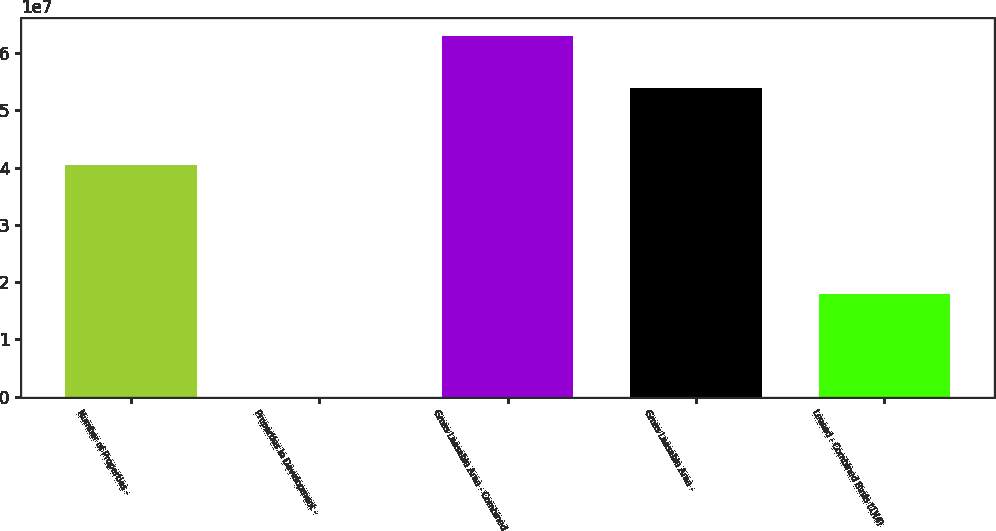Convert chart. <chart><loc_0><loc_0><loc_500><loc_500><bar_chart><fcel>Number of Properties -<fcel>Properties in Development -<fcel>Gross Leasable Area - Combined<fcel>Gross Leasable Area -<fcel>Leased - Combined Basis (1)(4)<nl><fcel>4.04748e+07<fcel>1<fcel>6.29607e+07<fcel>5.39664e+07<fcel>1.79888e+07<nl></chart> 